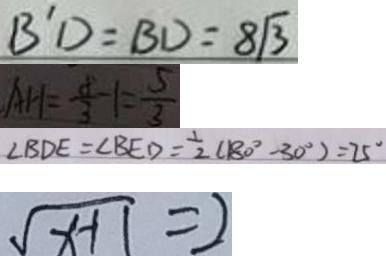<formula> <loc_0><loc_0><loc_500><loc_500>B ^ { \prime } D = B D = 8 \sqrt { 3 } 
 A H = \frac { 8 } { 3 } - 1 = \frac { 5 } { 3 } 
 \angle B D E = \angle B E D = \frac { 1 } { 2 } ( 1 8 0 ^ { \circ } - 3 0 ^ { \circ } ) = 2 5 ^ { \circ } 
 \sqrt { x - 1 } = 2</formula> 